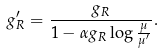<formula> <loc_0><loc_0><loc_500><loc_500>g _ { R } ^ { \prime } = \frac { g _ { R } } { 1 - \alpha g _ { R } \log \frac { \mu } { \mu ^ { \prime } } } .</formula> 